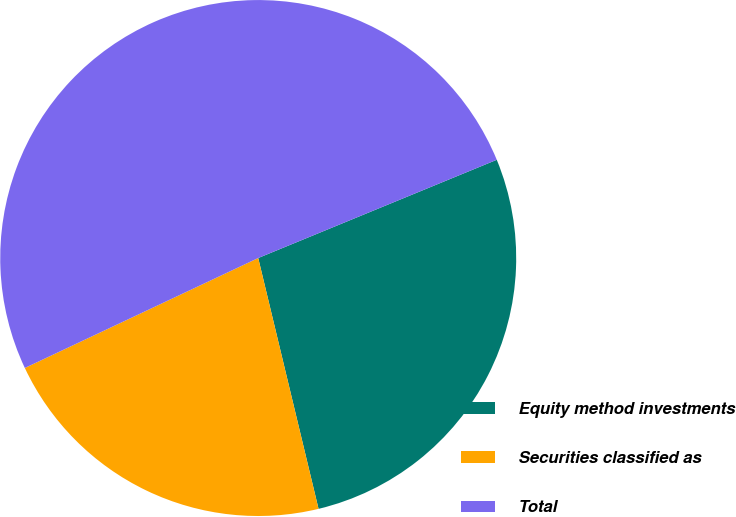Convert chart. <chart><loc_0><loc_0><loc_500><loc_500><pie_chart><fcel>Equity method investments<fcel>Securities classified as<fcel>Total<nl><fcel>27.46%<fcel>21.75%<fcel>50.79%<nl></chart> 